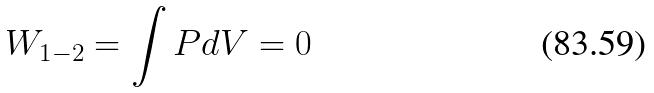Convert formula to latex. <formula><loc_0><loc_0><loc_500><loc_500>W _ { 1 - 2 } = \int P d V = 0</formula> 